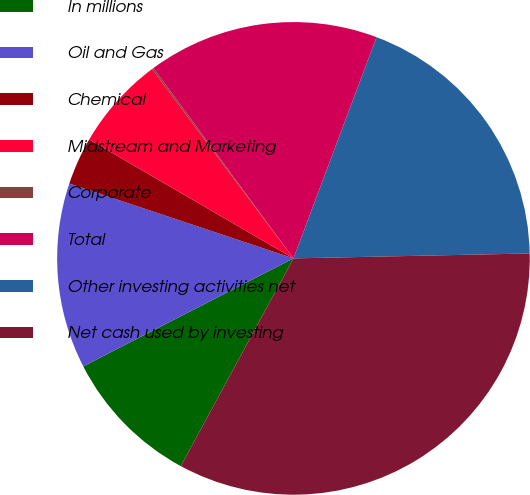Convert chart to OTSL. <chart><loc_0><loc_0><loc_500><loc_500><pie_chart><fcel>In millions<fcel>Oil and Gas<fcel>Chemical<fcel>Midstream and Marketing<fcel>Corporate<fcel>Total<fcel>Other investing activities net<fcel>Net cash used by investing<nl><fcel>9.54%<fcel>12.68%<fcel>3.26%<fcel>6.4%<fcel>0.12%<fcel>15.81%<fcel>18.95%<fcel>33.24%<nl></chart> 